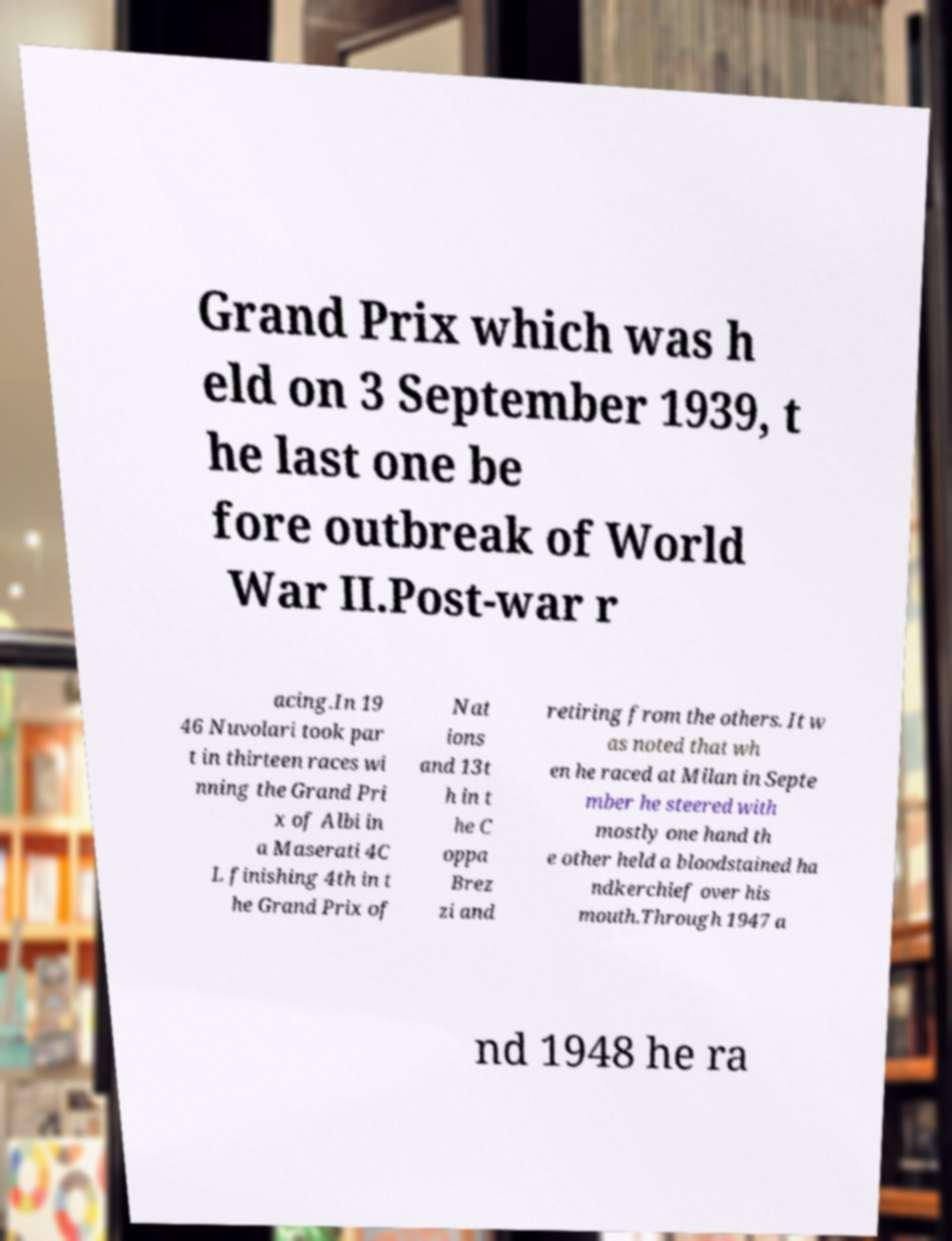There's text embedded in this image that I need extracted. Can you transcribe it verbatim? Grand Prix which was h eld on 3 September 1939, t he last one be fore outbreak of World War II.Post-war r acing.In 19 46 Nuvolari took par t in thirteen races wi nning the Grand Pri x of Albi in a Maserati 4C L finishing 4th in t he Grand Prix of Nat ions and 13t h in t he C oppa Brez zi and retiring from the others. It w as noted that wh en he raced at Milan in Septe mber he steered with mostly one hand th e other held a bloodstained ha ndkerchief over his mouth.Through 1947 a nd 1948 he ra 